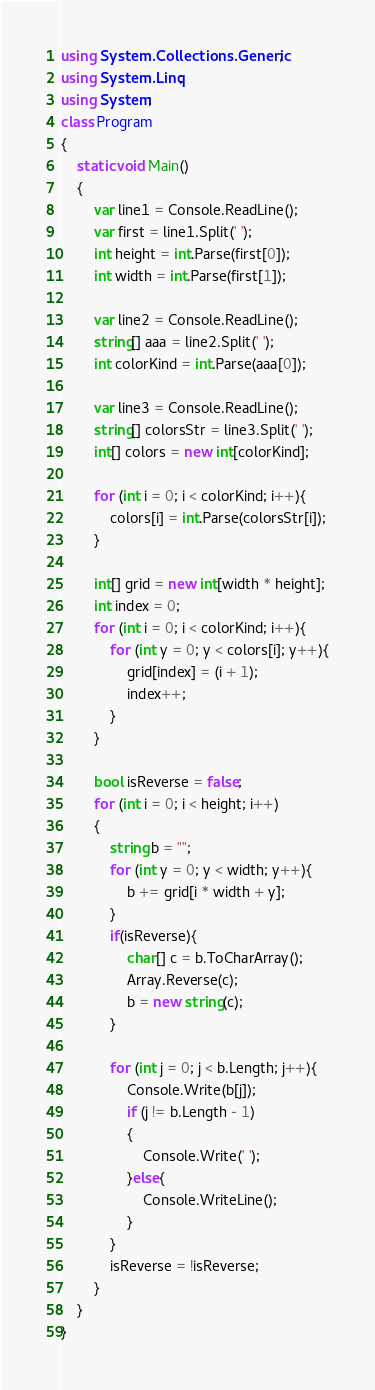Convert code to text. <code><loc_0><loc_0><loc_500><loc_500><_C#_>using System.Collections.Generic;
using System.Linq;
using System;
class Program
{
	static void Main()
	{
        var line1 = Console.ReadLine();
        var first = line1.Split(' ');
        int height = int.Parse(first[0]);
        int width = int.Parse(first[1]);

        var line2 = Console.ReadLine();
        string[] aaa = line2.Split(' ');
        int colorKind = int.Parse(aaa[0]);

        var line3 = Console.ReadLine();
        string[] colorsStr = line3.Split(' ');
        int[] colors = new int[colorKind];

        for (int i = 0; i < colorKind; i++){
            colors[i] = int.Parse(colorsStr[i]);
        }

        int[] grid = new int[width * height];
        int index = 0;
        for (int i = 0; i < colorKind; i++){
            for (int y = 0; y < colors[i]; y++){
                grid[index] = (i + 1);
                index++;
            }
        }

        bool isReverse = false;
        for (int i = 0; i < height; i++)
		{
            string b = "";
            for (int y = 0; y < width; y++){
                b += grid[i * width + y];
            }
            if(isReverse){
				char[] c = b.ToCharArray();
				Array.Reverse(c);
				b = new string(c);
            }

            for (int j = 0; j < b.Length; j++){
                Console.Write(b[j]);
                if (j != b.Length - 1)
                {
                    Console.Write(' ');
                }else{
                    Console.WriteLine();
                }
            }
            isReverse = !isReverse;
		}
	}
}</code> 